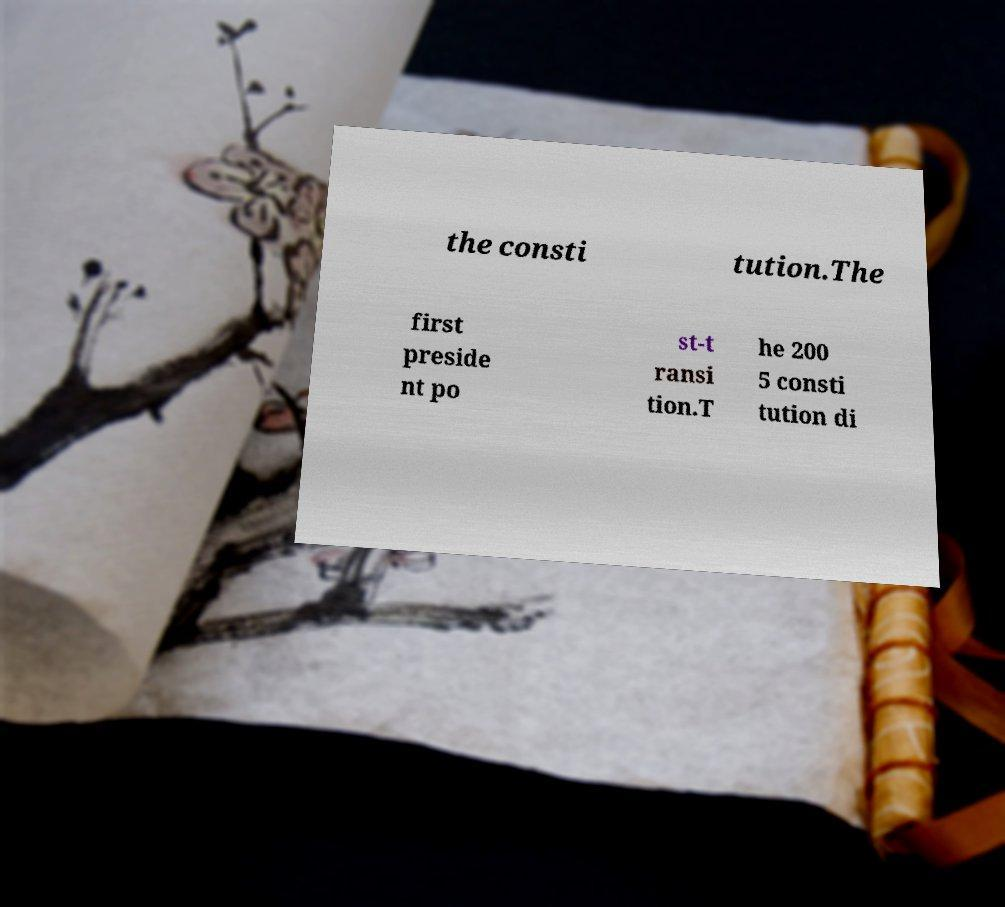What messages or text are displayed in this image? I need them in a readable, typed format. the consti tution.The first preside nt po st-t ransi tion.T he 200 5 consti tution di 